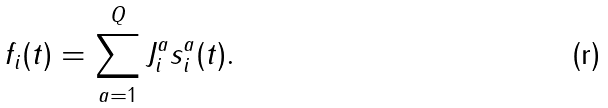Convert formula to latex. <formula><loc_0><loc_0><loc_500><loc_500>f _ { i } ( t ) = \sum _ { a = 1 } ^ { Q } J _ { i } ^ { a } s _ { i } ^ { a } ( t ) .</formula> 